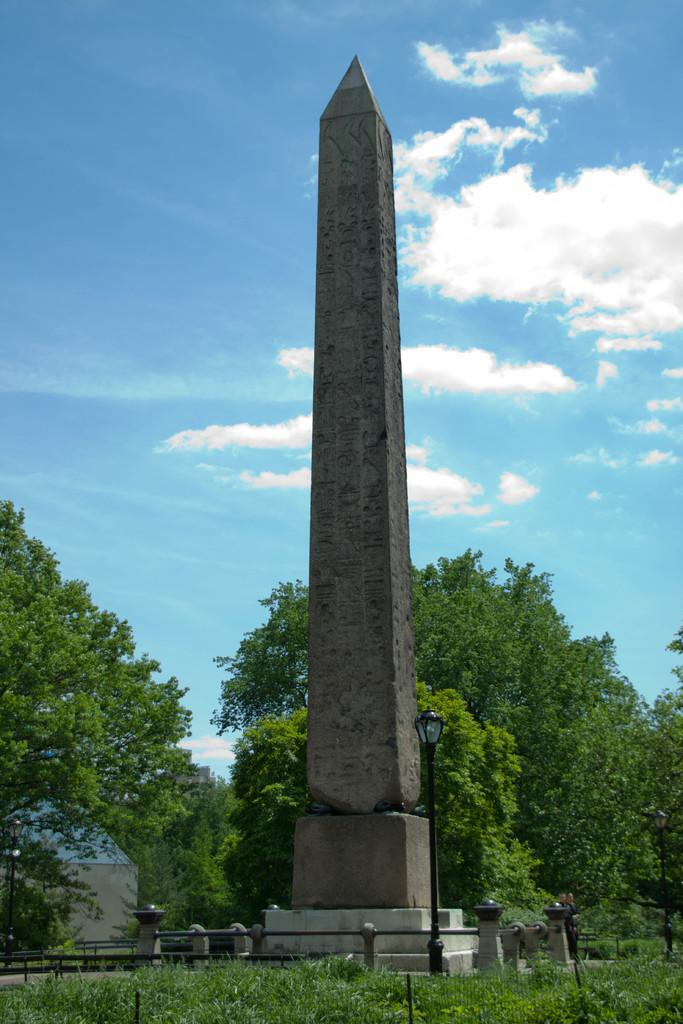What is located at the bottom of the image? There are plants, a fence, and light poles at the bottom of the image. What type of structure can be seen in the image? There is an obelisk in the image. What type of vegetation is present in the image? There are trees in the image. What can be seen in the sky in the image? There are clouds in the sky. What type of canvas is used to create the ornament in the image? There is no ornament present in the image; it features plants, a fence, light poles, an obelisk, trees, and clouds. What operation is being performed on the obelisk in the image? There is no operation being performed on the obelisk in the image; it is a stationary structure. 